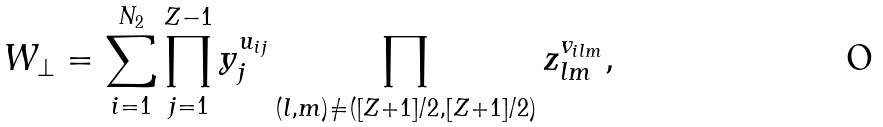Convert formula to latex. <formula><loc_0><loc_0><loc_500><loc_500>W _ { \perp } = \sum _ { i = 1 } ^ { N _ { 2 } } \prod _ { j = 1 } ^ { Z - 1 } y _ { j } ^ { u _ { i j } } \prod _ { ( l , m ) \neq ( [ Z + 1 ] / 2 , [ Z + 1 ] / 2 ) } z _ { l m } ^ { v _ { i l m } } ,</formula> 